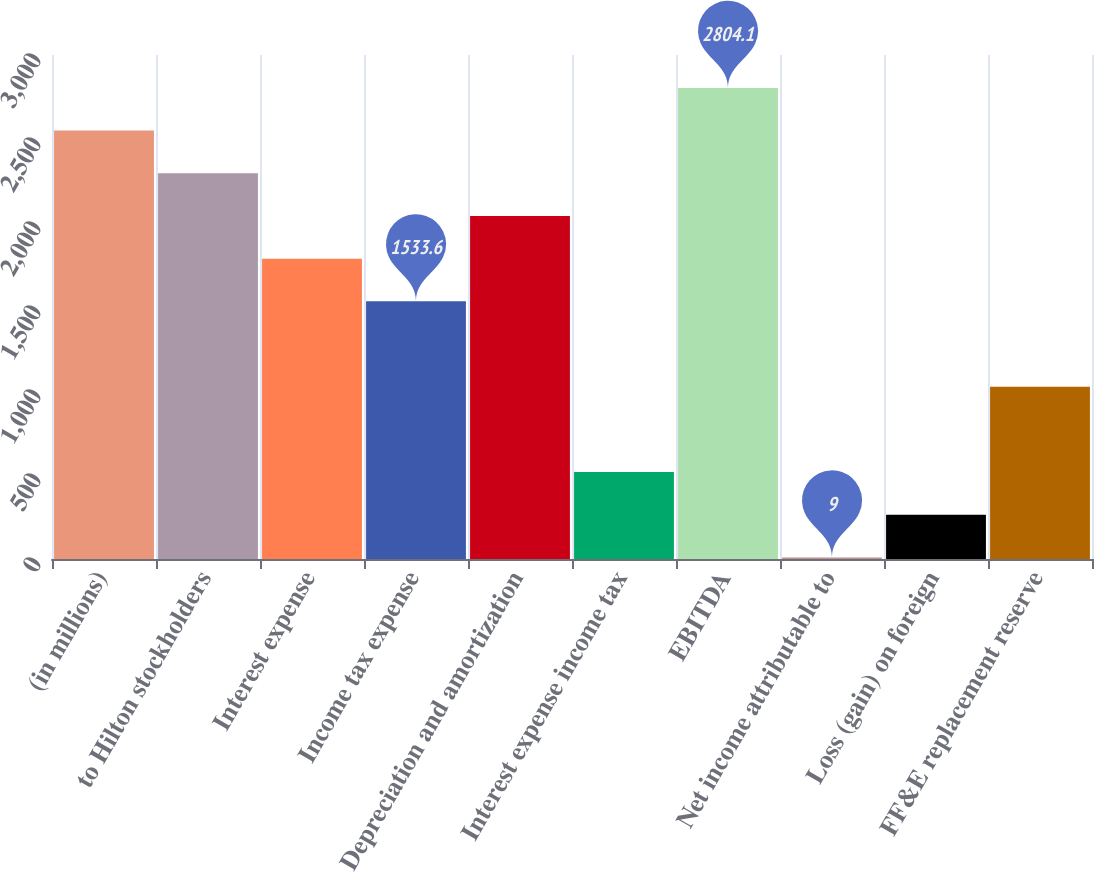Convert chart. <chart><loc_0><loc_0><loc_500><loc_500><bar_chart><fcel>(in millions)<fcel>to Hilton stockholders<fcel>Interest expense<fcel>Income tax expense<fcel>Depreciation and amortization<fcel>Interest expense income tax<fcel>EBITDA<fcel>Net income attributable to<fcel>Loss (gain) on foreign<fcel>FF&E replacement reserve<nl><fcel>2550<fcel>2295.9<fcel>1787.7<fcel>1533.6<fcel>2041.8<fcel>517.2<fcel>2804.1<fcel>9<fcel>263.1<fcel>1025.4<nl></chart> 